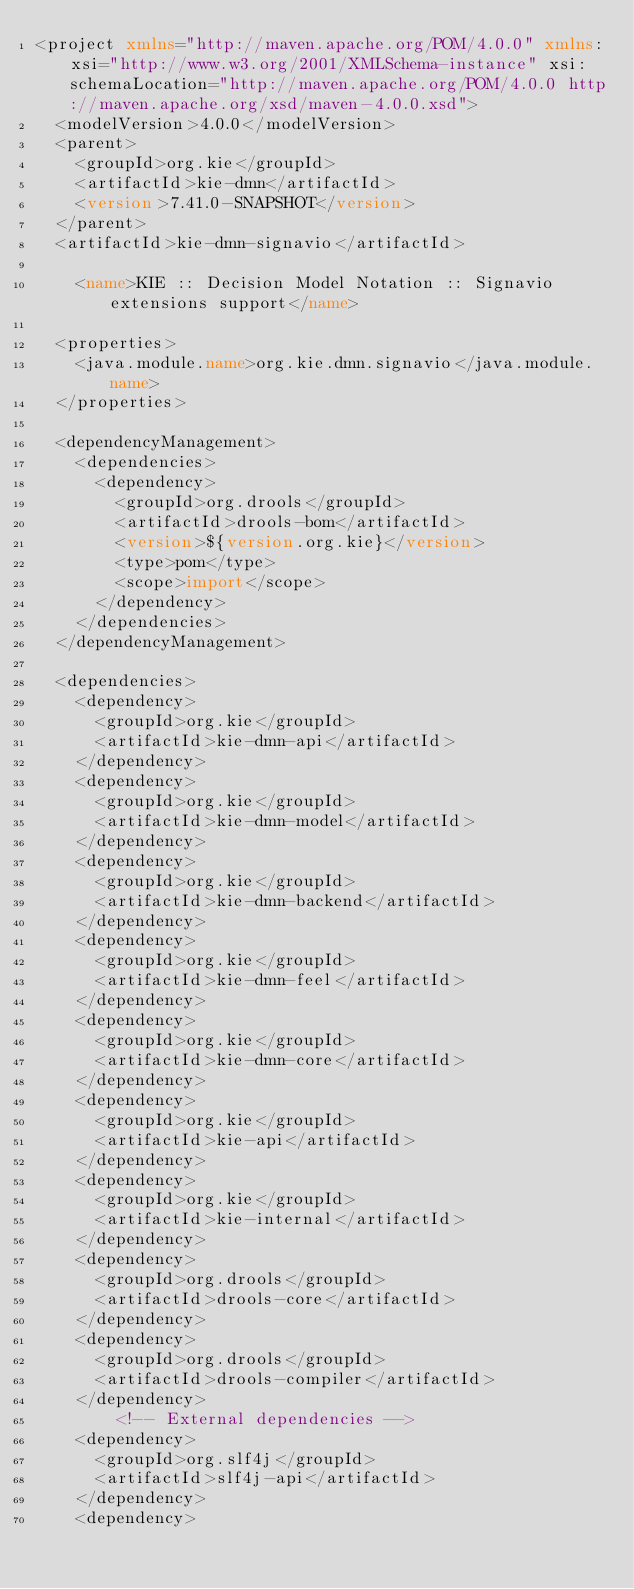Convert code to text. <code><loc_0><loc_0><loc_500><loc_500><_XML_><project xmlns="http://maven.apache.org/POM/4.0.0" xmlns:xsi="http://www.w3.org/2001/XMLSchema-instance" xsi:schemaLocation="http://maven.apache.org/POM/4.0.0 http://maven.apache.org/xsd/maven-4.0.0.xsd">
  <modelVersion>4.0.0</modelVersion>
  <parent>
    <groupId>org.kie</groupId>
    <artifactId>kie-dmn</artifactId>
    <version>7.41.0-SNAPSHOT</version>
  </parent>
  <artifactId>kie-dmn-signavio</artifactId>
  
    <name>KIE :: Decision Model Notation :: Signavio extensions support</name>
  
  <properties>
    <java.module.name>org.kie.dmn.signavio</java.module.name>
  </properties>

  <dependencyManagement>
    <dependencies>
      <dependency>
        <groupId>org.drools</groupId>
        <artifactId>drools-bom</artifactId>
        <version>${version.org.kie}</version>
        <type>pom</type>
        <scope>import</scope>
      </dependency>
    </dependencies>
  </dependencyManagement>

  <dependencies>
    <dependency>
      <groupId>org.kie</groupId>
      <artifactId>kie-dmn-api</artifactId>
    </dependency>
    <dependency>
      <groupId>org.kie</groupId>
      <artifactId>kie-dmn-model</artifactId>
    </dependency>
    <dependency>
      <groupId>org.kie</groupId>
      <artifactId>kie-dmn-backend</artifactId>
    </dependency>
    <dependency>
      <groupId>org.kie</groupId>
      <artifactId>kie-dmn-feel</artifactId>
    </dependency>
    <dependency>
      <groupId>org.kie</groupId>
      <artifactId>kie-dmn-core</artifactId>
    </dependency>
    <dependency>
      <groupId>org.kie</groupId>
      <artifactId>kie-api</artifactId>
    </dependency>
    <dependency>
      <groupId>org.kie</groupId>
      <artifactId>kie-internal</artifactId>
    </dependency>
    <dependency>
      <groupId>org.drools</groupId>
      <artifactId>drools-core</artifactId>
    </dependency>
    <dependency>
      <groupId>org.drools</groupId>
      <artifactId>drools-compiler</artifactId>
    </dependency>
        <!-- External dependencies -->
    <dependency>
      <groupId>org.slf4j</groupId>
      <artifactId>slf4j-api</artifactId>
    </dependency>
    <dependency></code> 